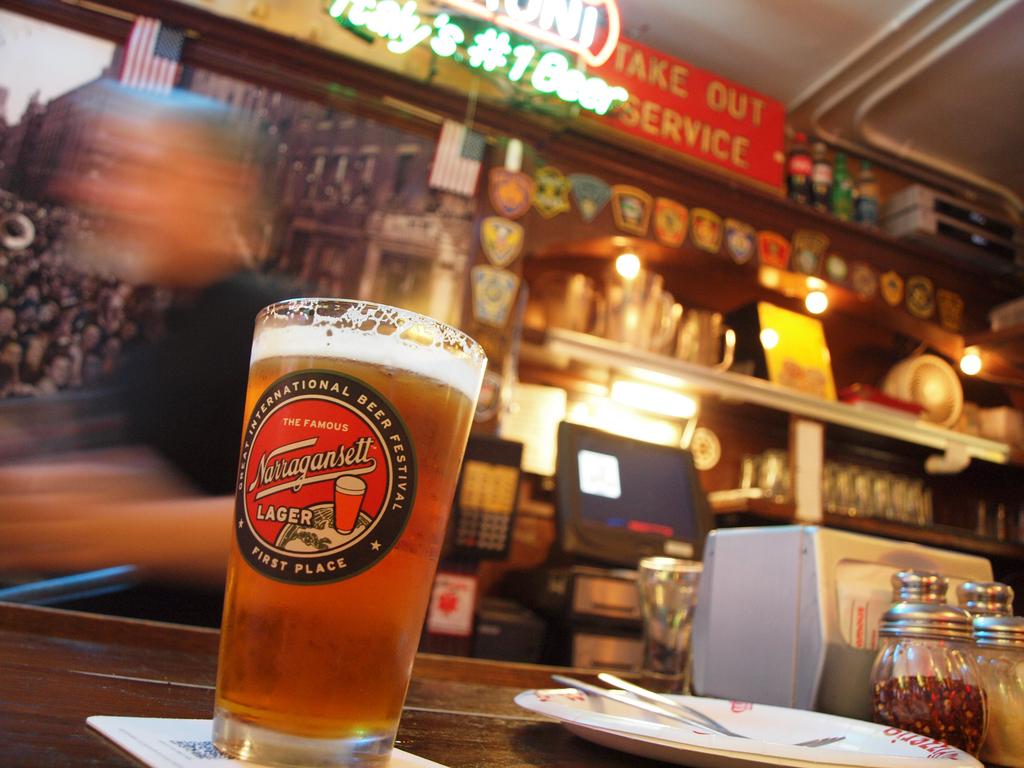What kind of service is offered on top?
Your answer should be very brief. Take out. 